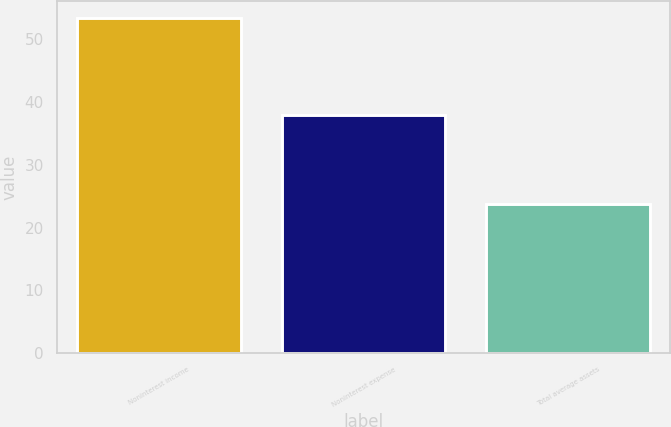Convert chart. <chart><loc_0><loc_0><loc_500><loc_500><bar_chart><fcel>Noninterest income<fcel>Noninterest expense<fcel>Total average assets<nl><fcel>53.4<fcel>38<fcel>23.7<nl></chart> 